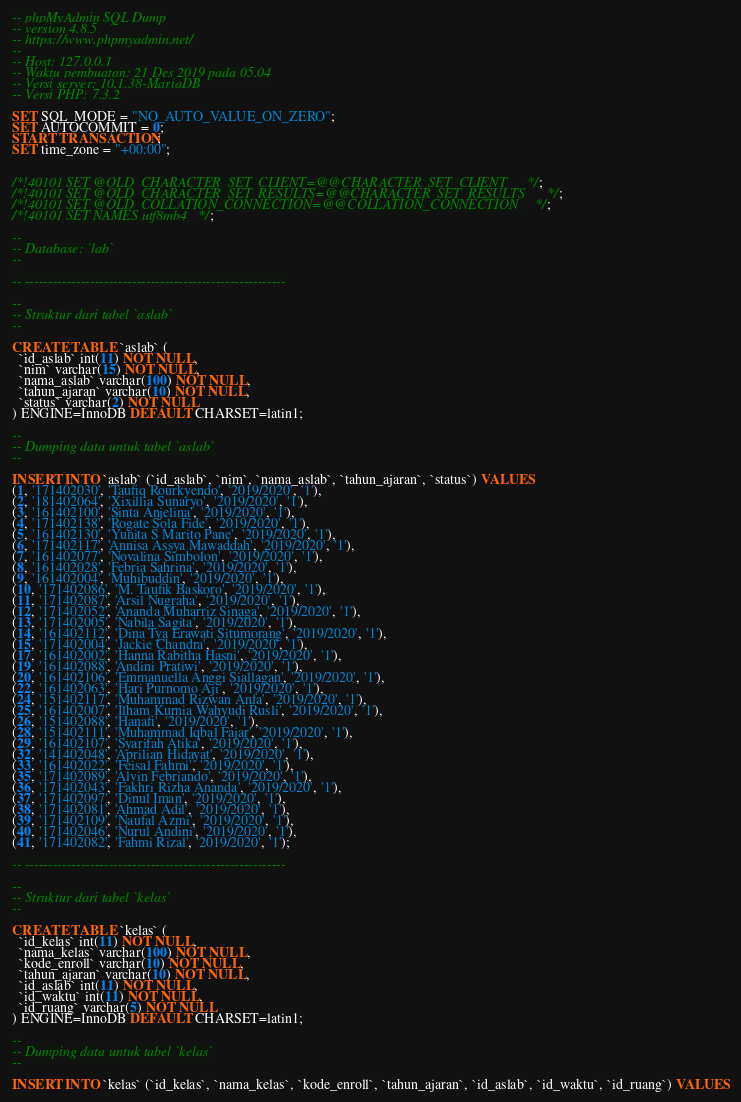Convert code to text. <code><loc_0><loc_0><loc_500><loc_500><_SQL_>-- phpMyAdmin SQL Dump
-- version 4.8.5
-- https://www.phpmyadmin.net/
--
-- Host: 127.0.0.1
-- Waktu pembuatan: 21 Des 2019 pada 05.04
-- Versi server: 10.1.38-MariaDB
-- Versi PHP: 7.3.2

SET SQL_MODE = "NO_AUTO_VALUE_ON_ZERO";
SET AUTOCOMMIT = 0;
START TRANSACTION;
SET time_zone = "+00:00";


/*!40101 SET @OLD_CHARACTER_SET_CLIENT=@@CHARACTER_SET_CLIENT */;
/*!40101 SET @OLD_CHARACTER_SET_RESULTS=@@CHARACTER_SET_RESULTS */;
/*!40101 SET @OLD_COLLATION_CONNECTION=@@COLLATION_CONNECTION */;
/*!40101 SET NAMES utf8mb4 */;

--
-- Database: `lab`
--

-- --------------------------------------------------------

--
-- Struktur dari tabel `aslab`
--

CREATE TABLE `aslab` (
  `id_aslab` int(11) NOT NULL,
  `nim` varchar(15) NOT NULL,
  `nama_aslab` varchar(100) NOT NULL,
  `tahun_ajaran` varchar(10) NOT NULL,
  `status` varchar(2) NOT NULL
) ENGINE=InnoDB DEFAULT CHARSET=latin1;

--
-- Dumping data untuk tabel `aslab`
--

INSERT INTO `aslab` (`id_aslab`, `nim`, `nama_aslab`, `tahun_ajaran`, `status`) VALUES
(1, '171402030', 'Taufiq Rourkyendo', '2019/2020', '1'),
(2, '181402064', 'Xixillia Sunaryo', '2019/2020', '1'),
(3, '161402100', 'Sinta Anjelina', '2019/2020', '1'),
(4, '171402138', 'Rogate Sola Fide', '2019/2020', '1'),
(5, '161402130', 'Yunita S Marito Pane', '2019/2020', '1'),
(6, '171402117', 'Annisa Assya Mawaddah', '2019/2020', '1'),
(7, '161402077', 'Novalina Simbolon', '2019/2020', '1'),
(8, '161402028', 'Febria Sahrina', '2019/2020', '1'),
(9, '161402004', 'Muhibuddin', '2019/2020', '1'),
(10, '171402086', 'M. Taufik Baskoro', '2019/2020', '1'),
(11, '171402087', 'Arsil Nugraha', '2019/2020', '1'),
(12, '171402052', 'Ananda Muharriz Sinaga', '2019/2020', '1'),
(13, '171402005', 'Nabila Sagita', '2019/2020', '1'),
(14, '161402112', 'Dina Tya Erawati Situmorang', '2019/2020', '1'),
(15, '171402004', 'Jackie Chandra', '2019/2020', '1'),
(17, '161402002', 'Hanna Rabitha Hasni', '2019/2020', '1'),
(19, '161402088', 'Andini Pratiwi', '2019/2020', '1'),
(20, '161402106', 'Emmanuella Anggi Siallagan', '2019/2020', '1'),
(22, '161402063', 'Hari Purnomo Aji', '2019/2020', '1'),
(24, '151402117', 'Muhammad Rizwan Anfa', '2019/2020', '1'),
(25, '161402007', 'Ilham Kurnia Wahyudi Rusli', '2019/2020', '1'),
(26, '151402088', 'Hanafi', '2019/2020', '1'),
(28, '151402111', 'Muhammad Iqbal Fajar', '2019/2020', '1'),
(29, '161402107', 'Syarifah Atika', '2019/2020', '1'),
(32, '141402048', 'Aprilian Hidayat', '2019/2020', '1'),
(33, '161402022', 'Feisal Fahmi', '2019/2020', '1'),
(35, '171402089', 'Alvin Febriando', '2019/2020', '1'),
(36, '171402043', 'Fakhri Rizha Ananda', '2019/2020', '1'),
(37, '171402097', 'Dinul Iman', '2019/2020', '1'),
(38, '171402081', 'Ahmad Adil', '2019/2020', '1'),
(39, '171402109', 'Naufal Azmi', '2019/2020', '1'),
(40, '171402046', 'Nurul Andini', '2019/2020', '1'),
(41, '171402082', 'Fahmi Rizal', '2019/2020', '1');

-- --------------------------------------------------------

--
-- Struktur dari tabel `kelas`
--

CREATE TABLE `kelas` (
  `id_kelas` int(11) NOT NULL,
  `nama_kelas` varchar(100) NOT NULL,
  `kode_enroll` varchar(10) NOT NULL,
  `tahun_ajaran` varchar(10) NOT NULL,
  `id_aslab` int(11) NOT NULL,
  `id_waktu` int(11) NOT NULL,
  `id_ruang` varchar(5) NOT NULL
) ENGINE=InnoDB DEFAULT CHARSET=latin1;

--
-- Dumping data untuk tabel `kelas`
--

INSERT INTO `kelas` (`id_kelas`, `nama_kelas`, `kode_enroll`, `tahun_ajaran`, `id_aslab`, `id_waktu`, `id_ruang`) VALUES</code> 